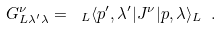<formula> <loc_0><loc_0><loc_500><loc_500>G ^ { \nu } _ { L \lambda ^ { \prime } \lambda } = \ _ { L } \langle p ^ { \prime } , \lambda ^ { \prime } | J ^ { \nu } | p , \lambda \rangle _ { L } \ .</formula> 